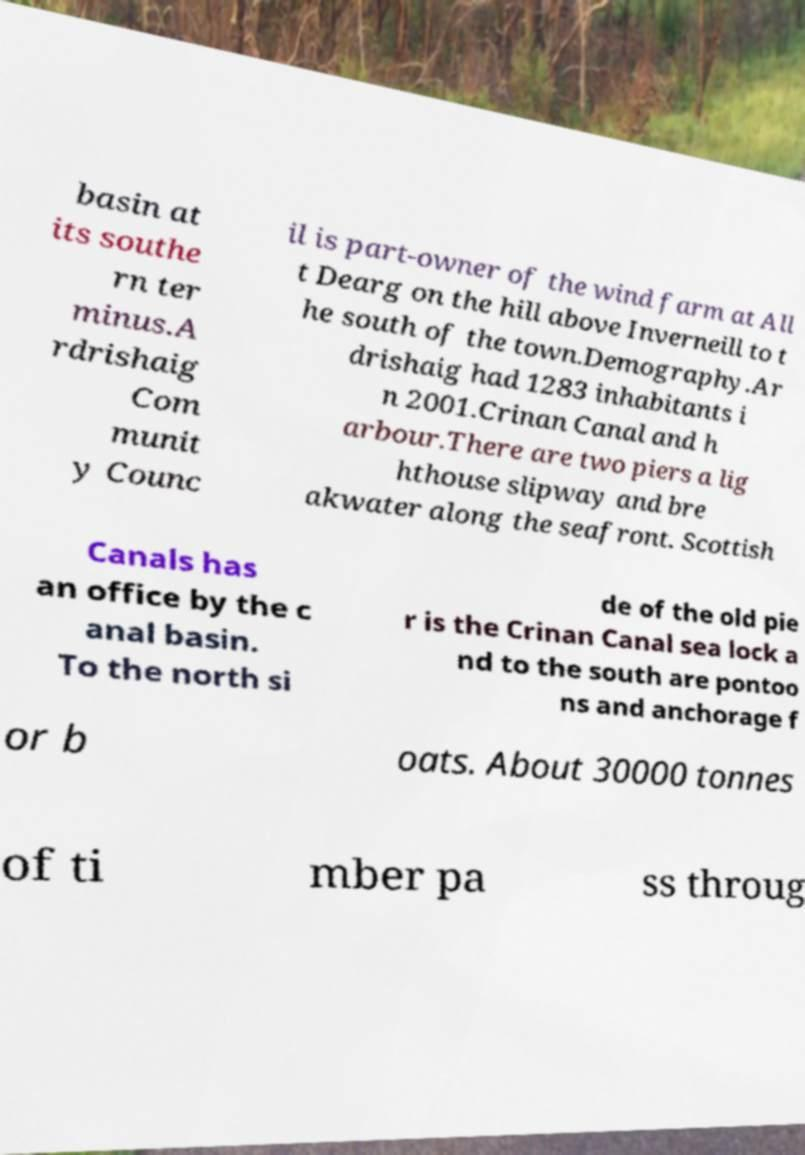Please read and relay the text visible in this image. What does it say? basin at its southe rn ter minus.A rdrishaig Com munit y Counc il is part-owner of the wind farm at All t Dearg on the hill above Inverneill to t he south of the town.Demography.Ar drishaig had 1283 inhabitants i n 2001.Crinan Canal and h arbour.There are two piers a lig hthouse slipway and bre akwater along the seafront. Scottish Canals has an office by the c anal basin. To the north si de of the old pie r is the Crinan Canal sea lock a nd to the south are pontoo ns and anchorage f or b oats. About 30000 tonnes of ti mber pa ss throug 